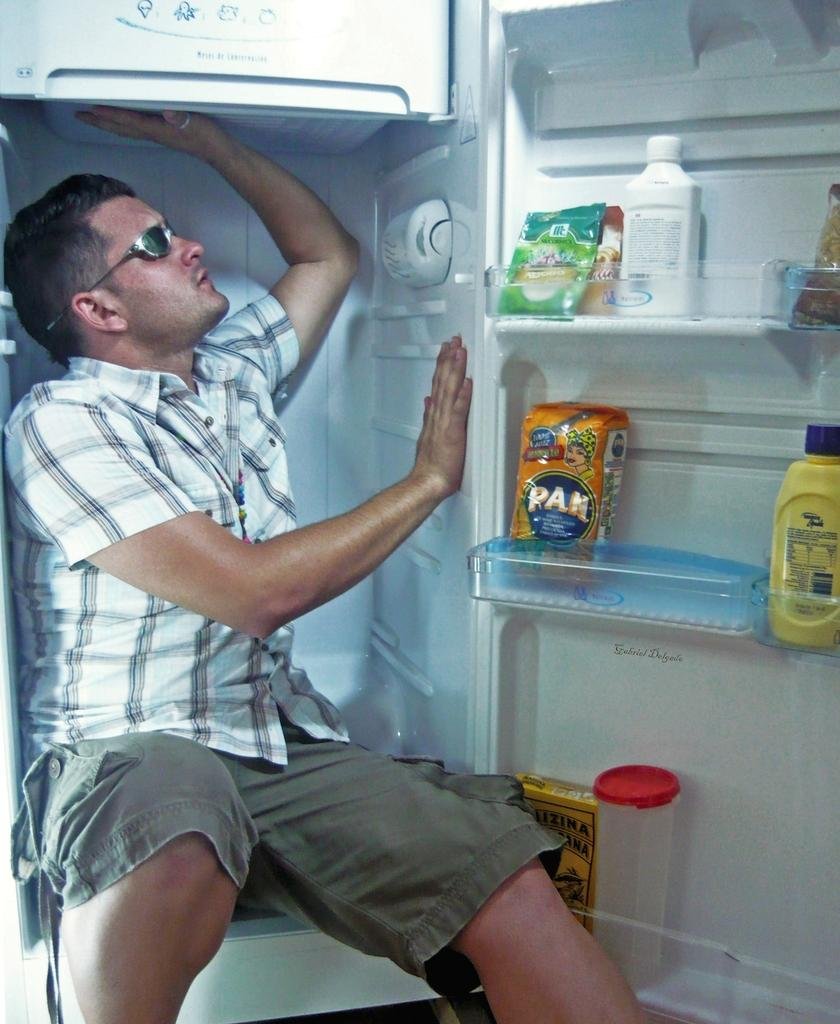What is the person in the image wearing? The person in the image is wearing goggles. Where is the person located in the image? The person is sitting inside a fridge. What can be seen on the door of the fridge? There are racks on the door of the fridge. What items are on the racks? There are bottles and packets on the racks. How many brothers does the person in the image have? There is no information about the person's brothers in the image. What attempt is the person making while sitting inside the fridge? There is no indication of an attempt being made by the person in the image. 